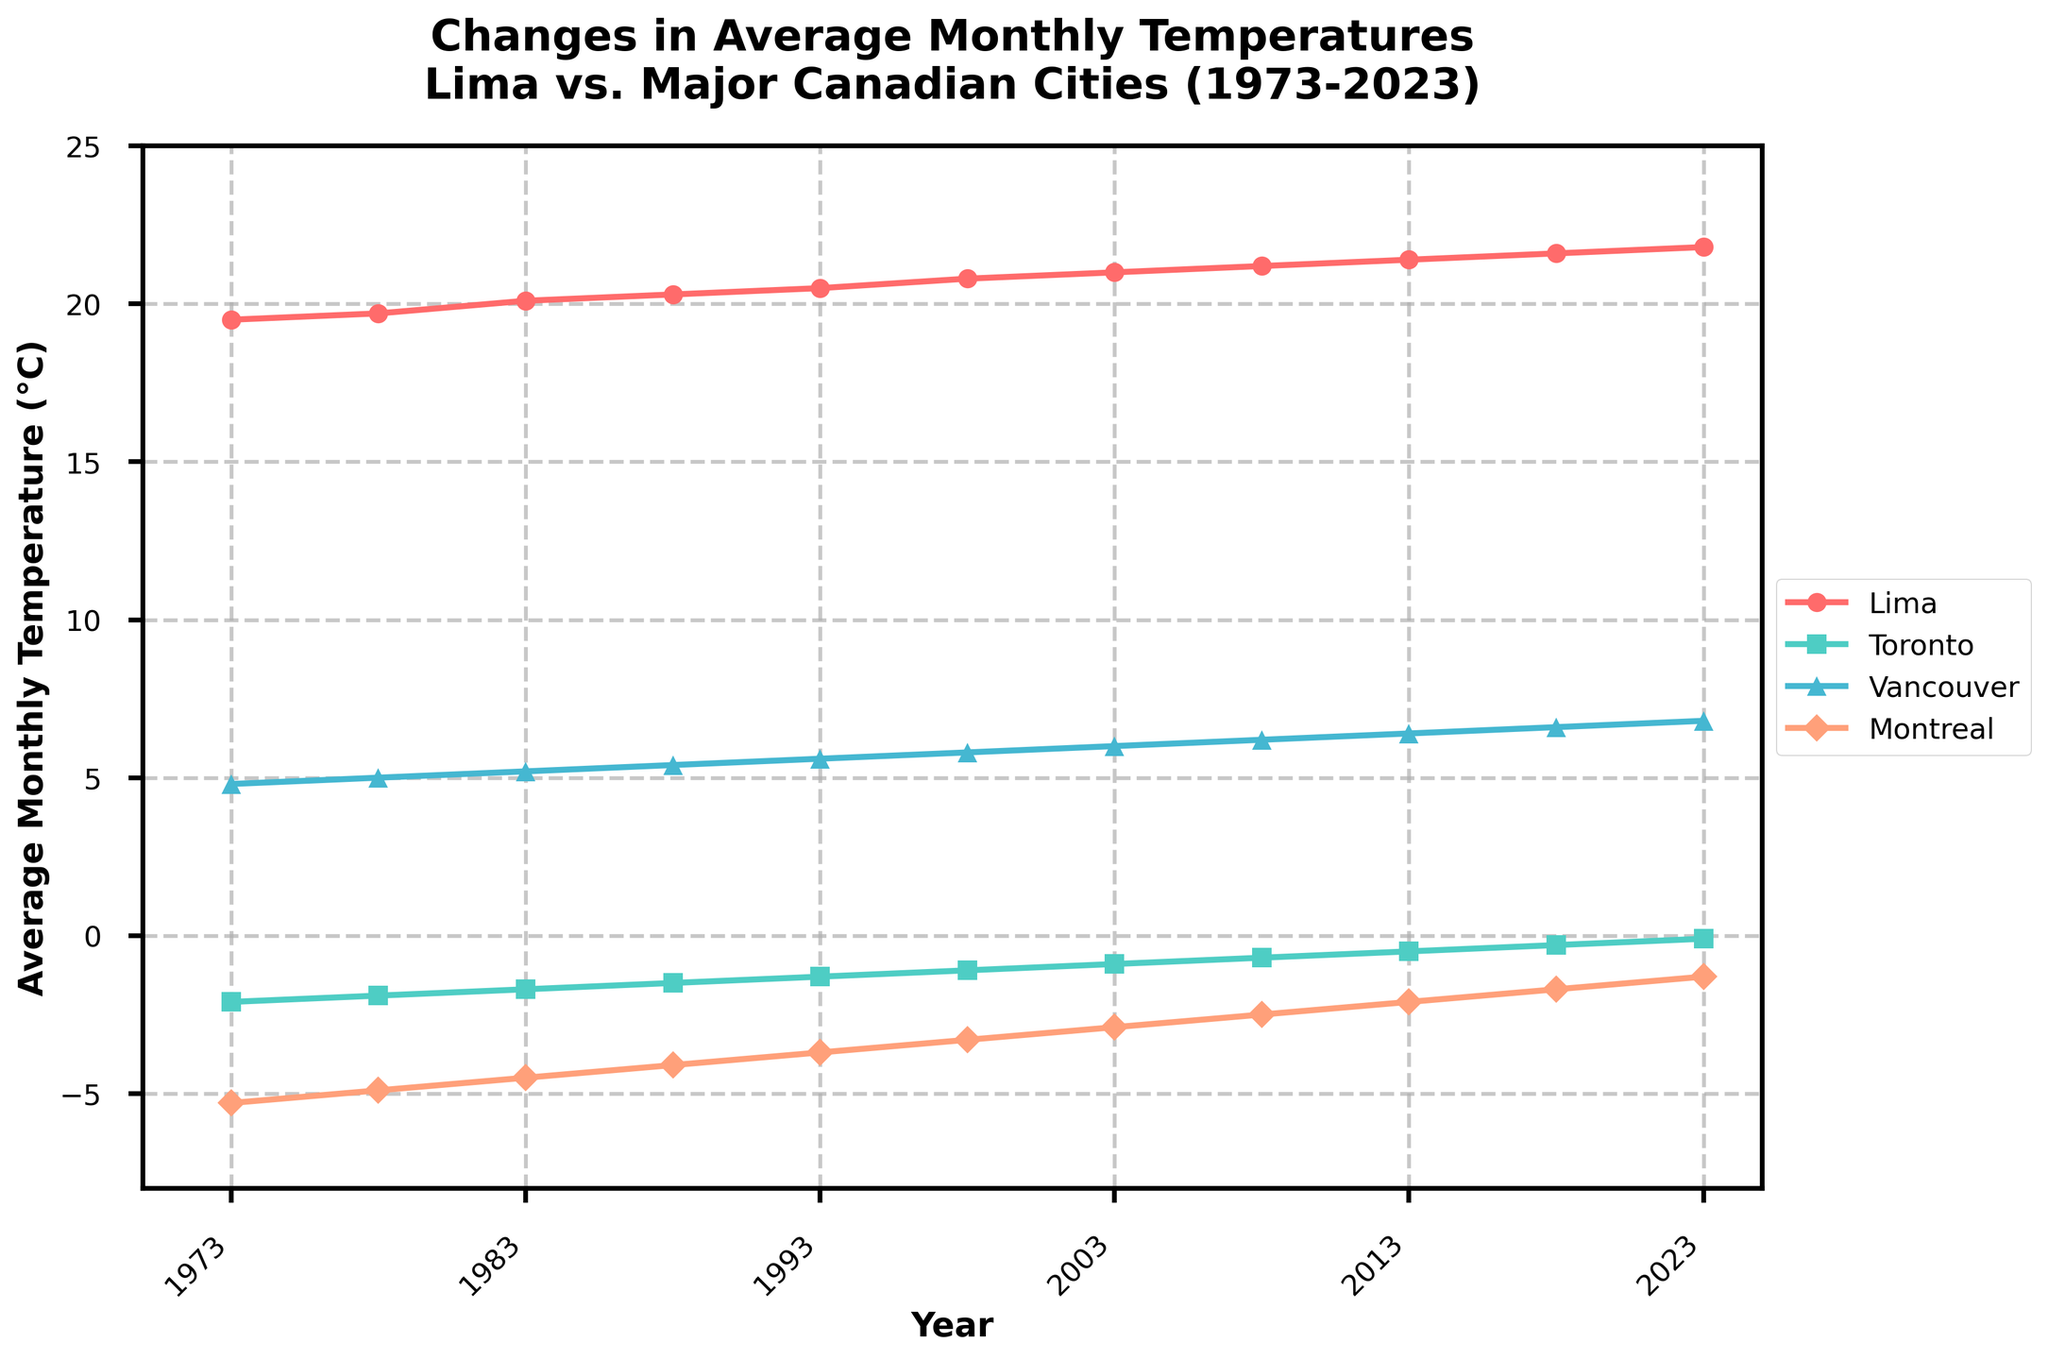What is the overall trend in average monthly temperatures for Lima from 1973 to 2023? The line for Lima shows a steady increase in average monthly temperatures over the period. Starting at 19.5°C in 1973 and rising consistently to 21.8°C in 2023.
Answer: Steady increase Which city had the lowest average monthly temperature in 2023? In the year 2023, the Toronto line is the lowest on the y-axis, indicating it had the lowest average monthly temperature.
Answer: Toronto How much did the average monthly temperature in Toronto change between 1973 and 2023? In 1973, Toronto's temperature was around -2.1°C, and by 2023, it was -0.1°C. The change is calculated as -0.1 - (-2.1) = 2.0°C.
Answer: 2.0°C Which city shows the most significant increase in average monthly temperatures over the 50-year period? By visually comparing the slopes of the lines, Lima shows the most significant increase as its temperature rises more consistently and by a larger margin than the other cities.
Answer: Lima How does the average monthly temperature of Vancouver in 2023 compare to that of Montreal in 2023? In 2023, Vancouver's average temperature is around 6.8°C, while Montreal's is about -1.3°C. Vancouver is significantly warmer.
Answer: Vancouver is warmer What is the average increase in monthly temperature per decade for Lima between 1973 and 2023? The total increase for Lima is from 19.5°C to 21.8°C, which is 21.8 - 19.5 = 2.3°C over 50 years. Per decade: 2.3°C / 5 = 0.46°C.
Answer: 0.46°C per decade In which year did Montreal experience a temperature closest to 0°C? By examining the Montreal line, around the year 2023, Montreal's temperature is closest to 0°C, approximately -1.3°C.
Answer: 2023 What visually distinguishes the Vancouver trend line from the other cities? The Vancouver line is represented by a blue color and shows a consistent upward trend in temperature, but it starts from a higher value compared to the Canadian cities, remaining positive throughout.
Answer: Blue line, starts from higher value and stays positive Which year shows the steepest increase in average monthly temperature for Lima? The steepest increase occurs between 1998 and 2003, as this segment of Lima's line has the most considerable upward slope.
Answer: Between 1998 and 2003 How does the rate of change in average monthly temperatures over time compare between Toronto and Montreal? Both Toronto and Montreal show similar rates of increase over time, but Montreal starts from a lower baseline and therefore remains lower overall.
Answer: Similar rate, but Montreal stays lower 